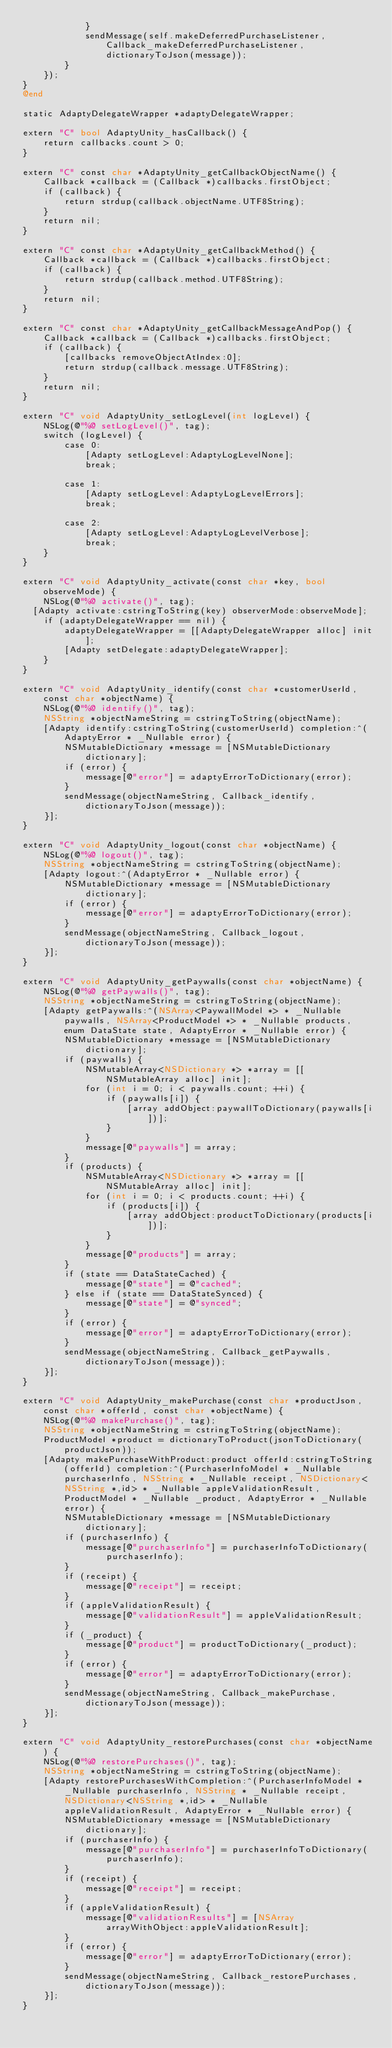<code> <loc_0><loc_0><loc_500><loc_500><_ObjectiveC_>            }
            sendMessage(self.makeDeferredPurchaseListener, Callback_makeDeferredPurchaseListener, dictionaryToJson(message));
        }
    });
}
@end

static AdaptyDelegateWrapper *adaptyDelegateWrapper;

extern "C" bool AdaptyUnity_hasCallback() {
    return callbacks.count > 0;
}

extern "C" const char *AdaptyUnity_getCallbackObjectName() {
    Callback *callback = (Callback *)callbacks.firstObject;
    if (callback) {
        return strdup(callback.objectName.UTF8String);
    }
    return nil;
}

extern "C" const char *AdaptyUnity_getCallbackMethod() {
    Callback *callback = (Callback *)callbacks.firstObject;
    if (callback) {
        return strdup(callback.method.UTF8String);
    }
    return nil;
}

extern "C" const char *AdaptyUnity_getCallbackMessageAndPop() {
    Callback *callback = (Callback *)callbacks.firstObject;
    if (callback) {
        [callbacks removeObjectAtIndex:0];
        return strdup(callback.message.UTF8String);
    }
    return nil;
}

extern "C" void AdaptyUnity_setLogLevel(int logLevel) {
    NSLog(@"%@ setLogLevel()", tag);
    switch (logLevel) {
        case 0:
            [Adapty setLogLevel:AdaptyLogLevelNone];
            break;
            
        case 1:
            [Adapty setLogLevel:AdaptyLogLevelErrors];
            break;
            
        case 2:
            [Adapty setLogLevel:AdaptyLogLevelVerbose];
            break;
    }
}

extern "C" void AdaptyUnity_activate(const char *key, bool observeMode) {
    NSLog(@"%@ activate()", tag);
	[Adapty activate:cstringToString(key) observerMode:observeMode];
    if (adaptyDelegateWrapper == nil) {
        adaptyDelegateWrapper = [[AdaptyDelegateWrapper alloc] init];
        [Adapty setDelegate:adaptyDelegateWrapper];
    }
}

extern "C" void AdaptyUnity_identify(const char *customerUserId, const char *objectName) {
    NSLog(@"%@ identify()", tag);
    NSString *objectNameString = cstringToString(objectName);
    [Adapty identify:cstringToString(customerUserId) completion:^(AdaptyError * _Nullable error) {
        NSMutableDictionary *message = [NSMutableDictionary dictionary];
        if (error) {
            message[@"error"] = adaptyErrorToDictionary(error);
        }
        sendMessage(objectNameString, Callback_identify, dictionaryToJson(message));
    }];
}

extern "C" void AdaptyUnity_logout(const char *objectName) {
    NSLog(@"%@ logout()", tag);
    NSString *objectNameString = cstringToString(objectName);
    [Adapty logout:^(AdaptyError * _Nullable error) {
        NSMutableDictionary *message = [NSMutableDictionary dictionary];
        if (error) {
            message[@"error"] = adaptyErrorToDictionary(error);
        }
        sendMessage(objectNameString, Callback_logout, dictionaryToJson(message));
    }];
}

extern "C" void AdaptyUnity_getPaywalls(const char *objectName) {
    NSLog(@"%@ getPaywalls()", tag);
    NSString *objectNameString = cstringToString(objectName);
    [Adapty getPaywalls:^(NSArray<PaywallModel *> * _Nullable paywalls, NSArray<ProductModel *> * _Nullable products, enum DataState state, AdaptyError * _Nullable error) {
        NSMutableDictionary *message = [NSMutableDictionary dictionary];
        if (paywalls) {
            NSMutableArray<NSDictionary *> *array = [[NSMutableArray alloc] init];
            for (int i = 0; i < paywalls.count; ++i) {
                if (paywalls[i]) {
                    [array addObject:paywallToDictionary(paywalls[i])];
                }
            }
            message[@"paywalls"] = array;
        }
        if (products) {
            NSMutableArray<NSDictionary *> *array = [[NSMutableArray alloc] init];
            for (int i = 0; i < products.count; ++i) {
                if (products[i]) {
                    [array addObject:productToDictionary(products[i])];
                }
            }
            message[@"products"] = array;
        }
        if (state == DataStateCached) {
            message[@"state"] = @"cached";
        } else if (state == DataStateSynced) {
            message[@"state"] = @"synced";
        }
        if (error) {
            message[@"error"] = adaptyErrorToDictionary(error);
        }
        sendMessage(objectNameString, Callback_getPaywalls, dictionaryToJson(message));
    }];
}

extern "C" void AdaptyUnity_makePurchase(const char *productJson, const char *offerId, const char *objectName) {
    NSLog(@"%@ makePurchase()", tag);
    NSString *objectNameString = cstringToString(objectName);
    ProductModel *product = dictionaryToProduct(jsonToDictionary(productJson));
    [Adapty makePurchaseWithProduct:product offerId:cstringToString(offerId) completion:^(PurchaserInfoModel * _Nullable purchaserInfo, NSString * _Nullable receipt, NSDictionary<NSString *,id> * _Nullable appleValidationResult, ProductModel * _Nullable _product, AdaptyError * _Nullable error) {
        NSMutableDictionary *message = [NSMutableDictionary dictionary];
        if (purchaserInfo) {
            message[@"purchaserInfo"] = purchaserInfoToDictionary(purchaserInfo);
        }
        if (receipt) {
            message[@"receipt"] = receipt;
        }
        if (appleValidationResult) {
            message[@"validationResult"] = appleValidationResult;
        }
        if (_product) {
            message[@"product"] = productToDictionary(_product);
        }
        if (error) {
            message[@"error"] = adaptyErrorToDictionary(error);
        }
        sendMessage(objectNameString, Callback_makePurchase, dictionaryToJson(message));
    }];
}

extern "C" void AdaptyUnity_restorePurchases(const char *objectName) {
    NSLog(@"%@ restorePurchases()", tag);
    NSString *objectNameString = cstringToString(objectName);
    [Adapty restorePurchasesWithCompletion:^(PurchaserInfoModel * _Nullable purchaserInfo, NSString * _Nullable receipt, NSDictionary<NSString *,id> * _Nullable appleValidationResult, AdaptyError * _Nullable error) {
        NSMutableDictionary *message = [NSMutableDictionary dictionary];
        if (purchaserInfo) {
            message[@"purchaserInfo"] = purchaserInfoToDictionary(purchaserInfo);
        }
        if (receipt) {
            message[@"receipt"] = receipt;
        }
        if (appleValidationResult) {
            message[@"validationResults"] = [NSArray arrayWithObject:appleValidationResult];
        }
        if (error) {
            message[@"error"] = adaptyErrorToDictionary(error);
        }
        sendMessage(objectNameString, Callback_restorePurchases, dictionaryToJson(message));
    }];
}
</code> 